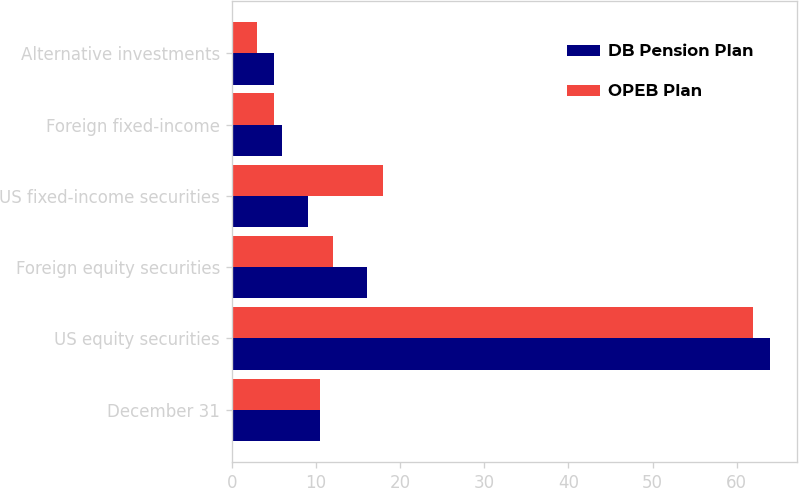Convert chart. <chart><loc_0><loc_0><loc_500><loc_500><stacked_bar_chart><ecel><fcel>December 31<fcel>US equity securities<fcel>Foreign equity securities<fcel>US fixed-income securities<fcel>Foreign fixed-income<fcel>Alternative investments<nl><fcel>DB Pension Plan<fcel>10.5<fcel>64<fcel>16<fcel>9<fcel>6<fcel>5<nl><fcel>OPEB Plan<fcel>10.5<fcel>62<fcel>12<fcel>18<fcel>5<fcel>3<nl></chart> 